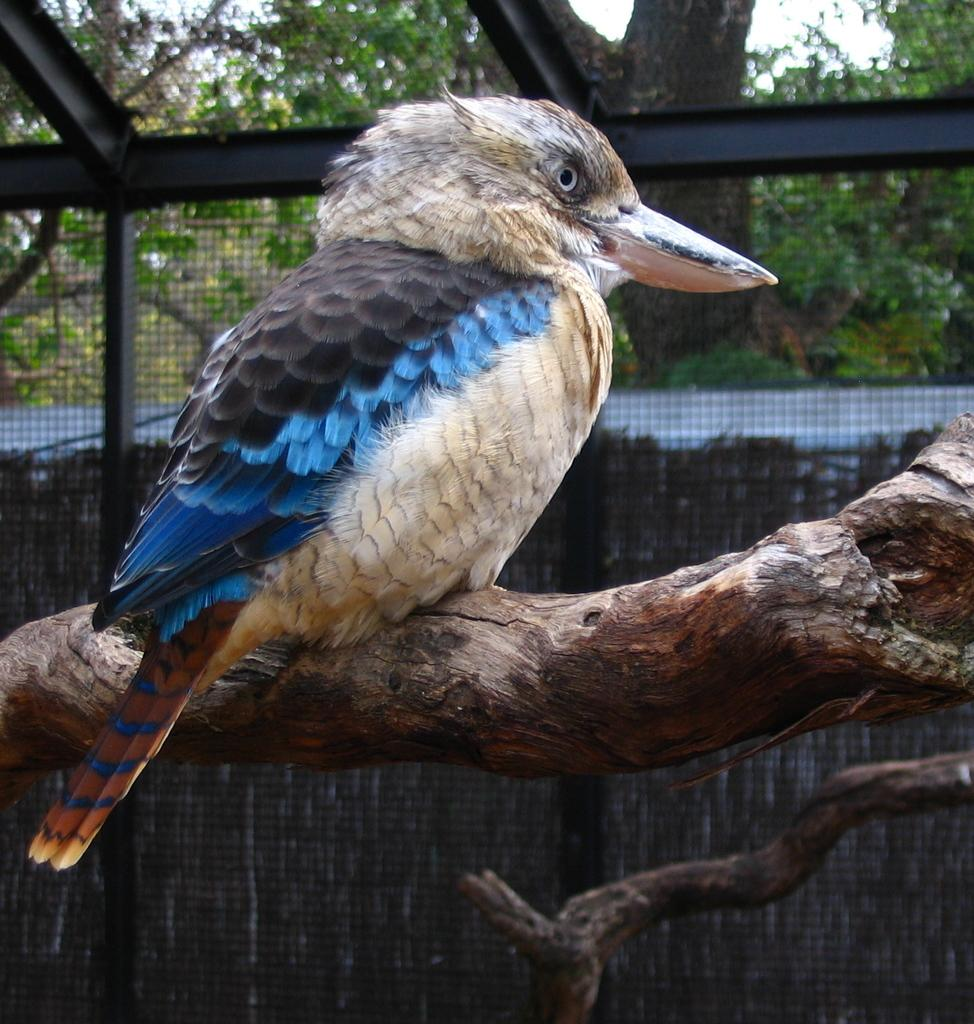What type of animal can be seen in the image? There is a bird in the image. Where is the bird located? The bird is sitting on a tree. What can be seen in the background of the image? There is a fence, trees, and the sky visible in the background of the image. What type of flowers can be seen in the bird's beak in the image? There are no flowers present in the image, nor are there any flowers in the bird's beak. 